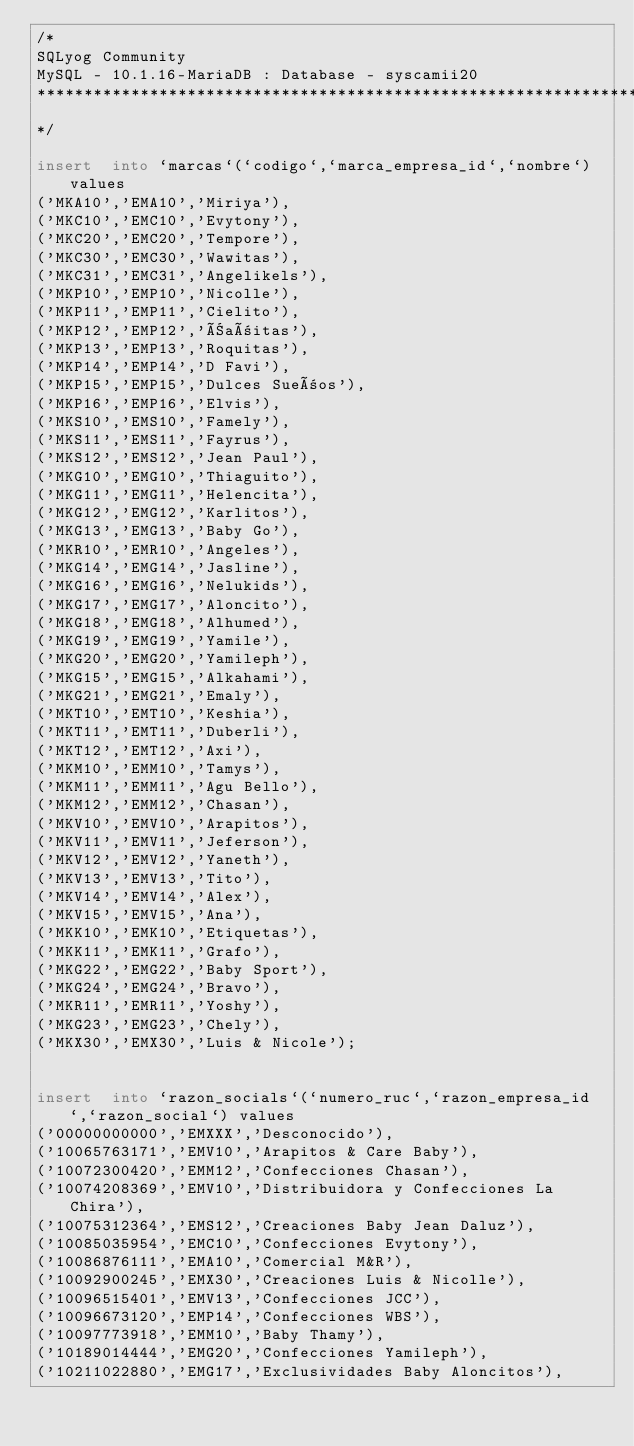<code> <loc_0><loc_0><loc_500><loc_500><_SQL_>/*
SQLyog Community
MySQL - 10.1.16-MariaDB : Database - syscamii20
*********************************************************************
*/

insert  into `marcas`(`codigo`,`marca_empresa_id`,`nombre`) values 
('MKA10','EMA10','Miriya'),
('MKC10','EMC10','Evytony'),
('MKC20','EMC20','Tempore'),
('MKC30','EMC30','Wawitas'),
('MKC31','EMC31','Angelikels'),
('MKP10','EMP10','Nicolle'),
('MKP11','EMP11','Cielito'),
('MKP12','EMP12','Ñañitas'),
('MKP13','EMP13','Roquitas'),
('MKP14','EMP14','D Favi'),
('MKP15','EMP15','Dulces Sueños'),
('MKP16','EMP16','Elvis'),
('MKS10','EMS10','Famely'),
('MKS11','EMS11','Fayrus'),
('MKS12','EMS12','Jean Paul'),
('MKG10','EMG10','Thiaguito'),
('MKG11','EMG11','Helencita'),
('MKG12','EMG12','Karlitos'),
('MKG13','EMG13','Baby Go'),
('MKR10','EMR10','Angeles'),
('MKG14','EMG14','Jasline'),
('MKG16','EMG16','Nelukids'),
('MKG17','EMG17','Aloncito'),
('MKG18','EMG18','Alhumed'),
('MKG19','EMG19','Yamile'),
('MKG20','EMG20','Yamileph'),
('MKG15','EMG15','Alkahami'),
('MKG21','EMG21','Emaly'),
('MKT10','EMT10','Keshia'),
('MKT11','EMT11','Duberli'),
('MKT12','EMT12','Axi'),
('MKM10','EMM10','Tamys'),
('MKM11','EMM11','Agu Bello'),
('MKM12','EMM12','Chasan'),
('MKV10','EMV10','Arapitos'),
('MKV11','EMV11','Jeferson'),
('MKV12','EMV12','Yaneth'),
('MKV13','EMV13','Tito'),
('MKV14','EMV14','Alex'),
('MKV15','EMV15','Ana'),
('MKK10','EMK10','Etiquetas'),
('MKK11','EMK11','Grafo'),
('MKG22','EMG22','Baby Sport'),
('MKG24','EMG24','Bravo'),
('MKR11','EMR11','Yoshy'),
('MKG23','EMG23','Chely'),
('MKX30','EMX30','Luis & Nicole');


insert  into `razon_socials`(`numero_ruc`,`razon_empresa_id`,`razon_social`) values 
('00000000000','EMXXX','Desconocido'),
('10065763171','EMV10','Arapitos & Care Baby'),
('10072300420','EMM12','Confecciones Chasan'),
('10074208369','EMV10','Distribuidora y Confecciones La Chira'),
('10075312364','EMS12','Creaciones Baby Jean Daluz'),
('10085035954','EMC10','Confecciones Evytony'),
('10086876111','EMA10','Comercial M&R'),
('10092900245','EMX30','Creaciones Luis & Nicolle'),
('10096515401','EMV13','Confecciones JCC'),
('10096673120','EMP14','Confecciones WBS'),
('10097773918','EMM10','Baby Thamy'),
('10189014444','EMG20','Confecciones Yamileph'),
('10211022880','EMG17','Exclusividades Baby Aloncitos'),</code> 